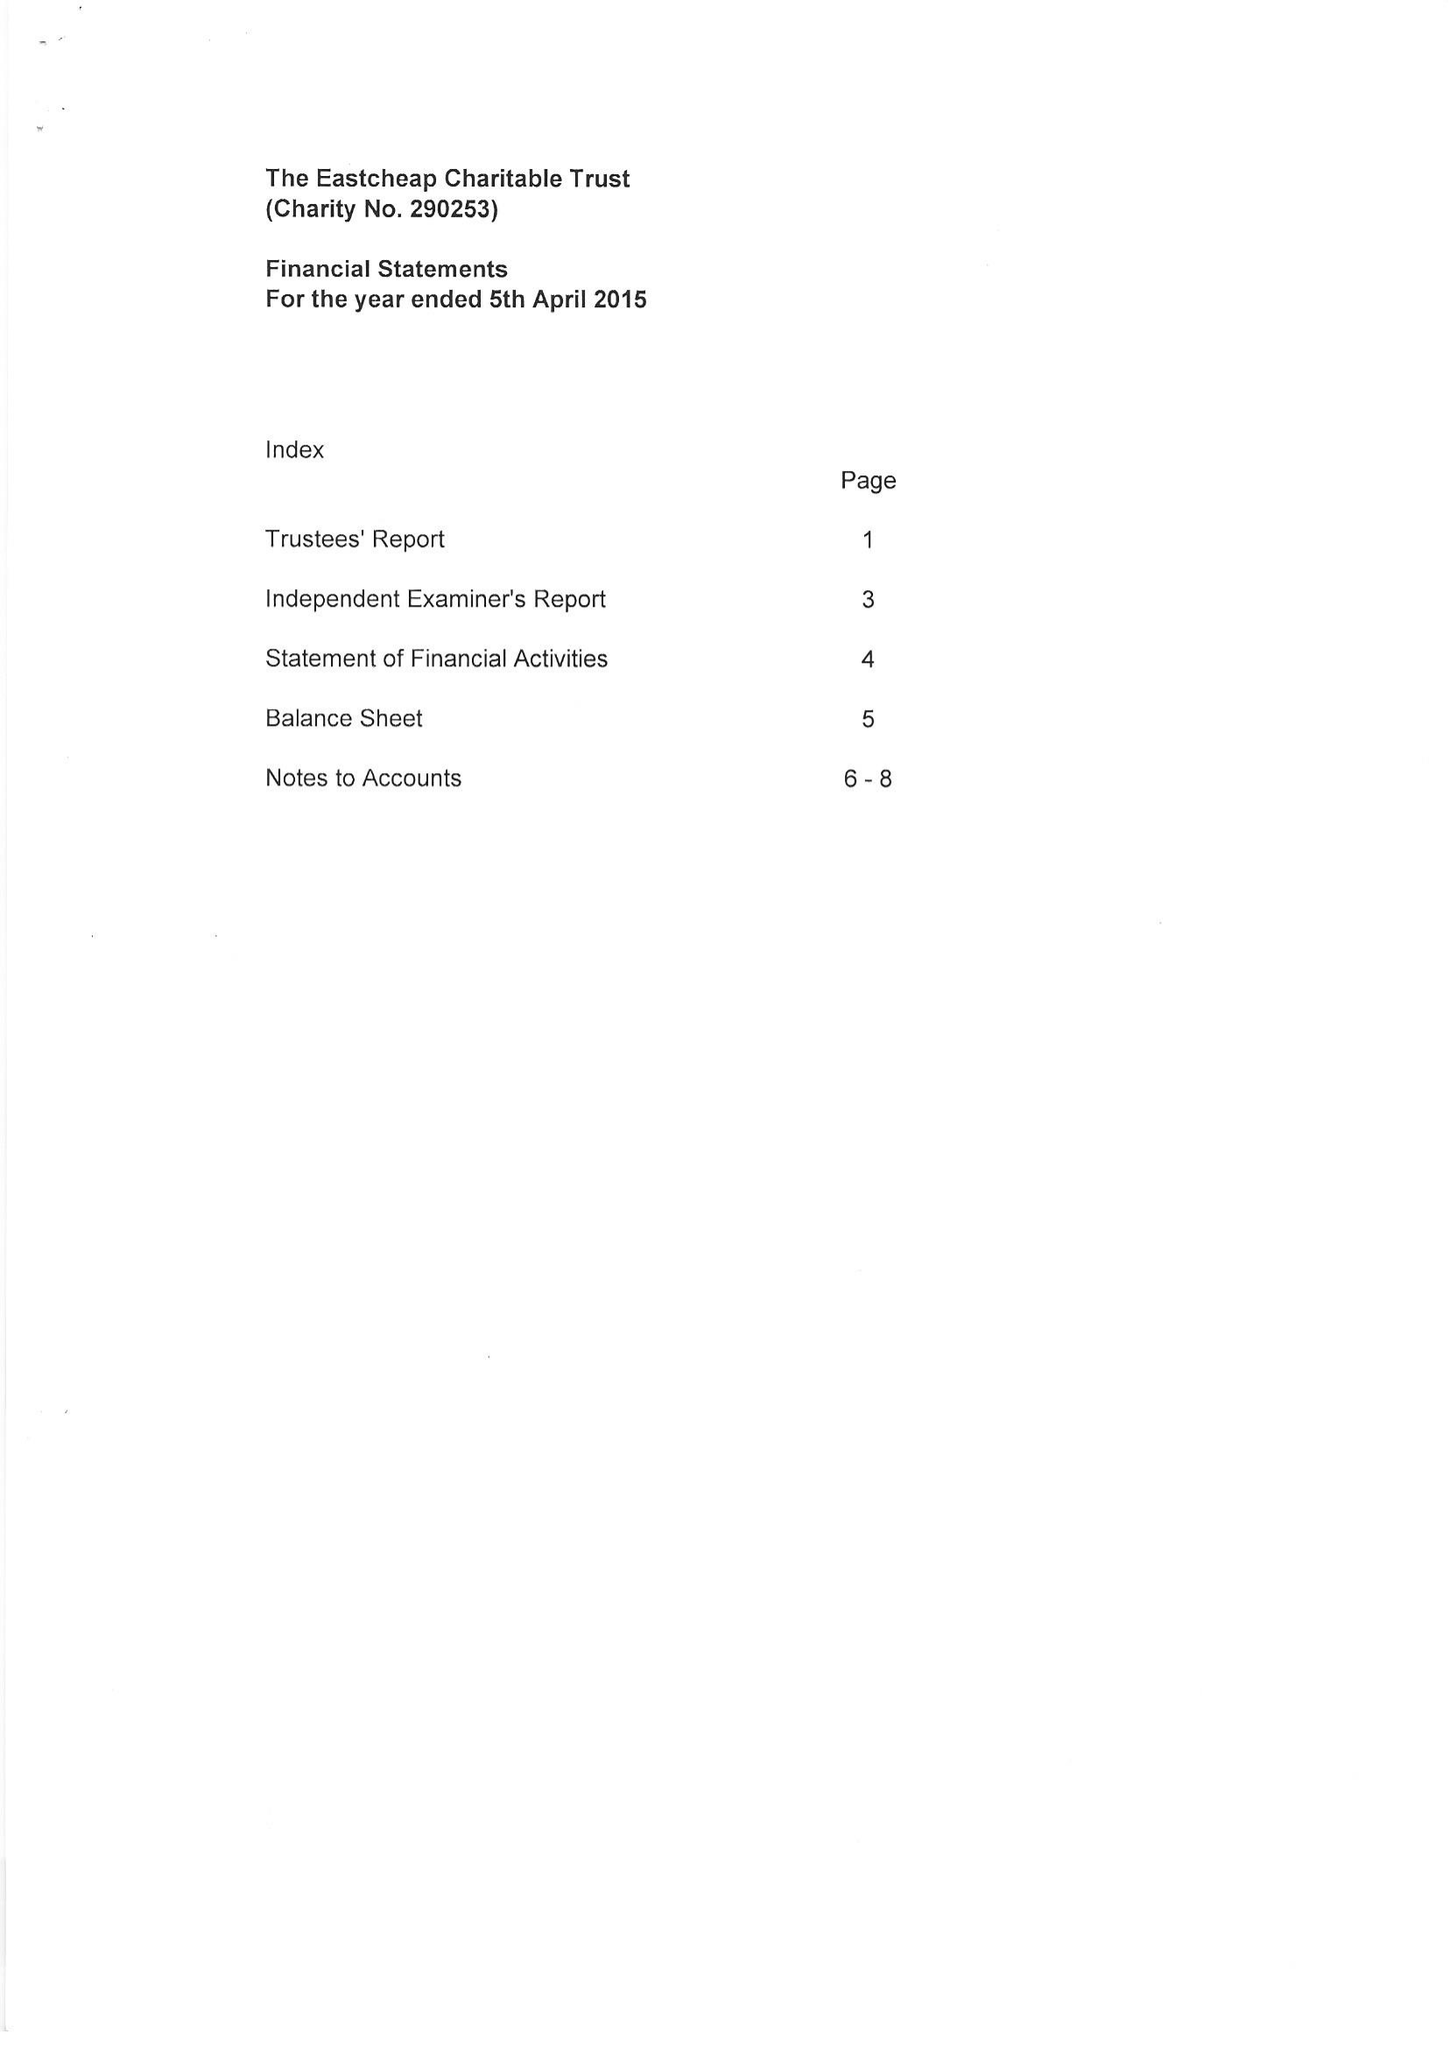What is the value for the charity_name?
Answer the question using a single word or phrase. The Eastcheap Charitable Trust 